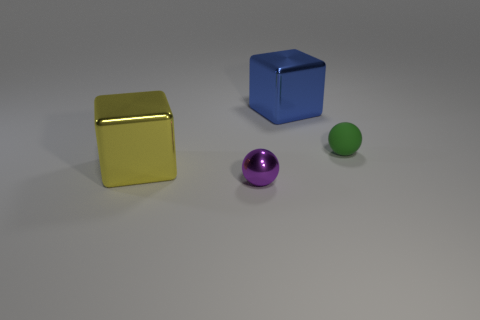Is there a purple thing that has the same shape as the small green thing?
Give a very brief answer. Yes. What is the size of the object that is right of the large blue metallic object?
Your answer should be compact. Small. There is another thing that is the same size as the purple object; what is its material?
Make the answer very short. Rubber. Is the number of small green spheres greater than the number of small balls?
Offer a very short reply. No. How big is the purple ball in front of the tiny object behind the shiny ball?
Offer a terse response. Small. There is a yellow metallic thing that is the same size as the blue metallic thing; what is its shape?
Provide a short and direct response. Cube. The shiny thing behind the cube left of the shiny cube that is to the right of the purple ball is what shape?
Give a very brief answer. Cube. How many metal spheres are there?
Make the answer very short. 1. There is a small purple thing; are there any yellow metal cubes behind it?
Ensure brevity in your answer.  Yes. Is the big object behind the small matte thing made of the same material as the ball behind the large yellow metal object?
Offer a terse response. No. 